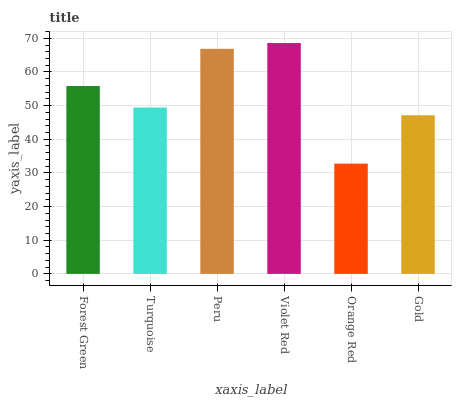Is Turquoise the minimum?
Answer yes or no. No. Is Turquoise the maximum?
Answer yes or no. No. Is Forest Green greater than Turquoise?
Answer yes or no. Yes. Is Turquoise less than Forest Green?
Answer yes or no. Yes. Is Turquoise greater than Forest Green?
Answer yes or no. No. Is Forest Green less than Turquoise?
Answer yes or no. No. Is Forest Green the high median?
Answer yes or no. Yes. Is Turquoise the low median?
Answer yes or no. Yes. Is Orange Red the high median?
Answer yes or no. No. Is Forest Green the low median?
Answer yes or no. No. 